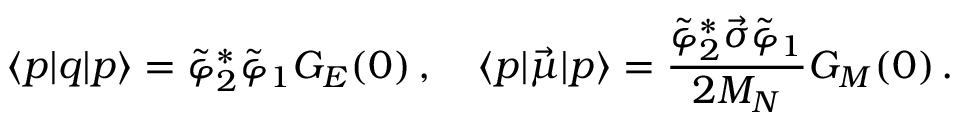<formula> <loc_0><loc_0><loc_500><loc_500>\langle p | q | p \rangle = \tilde { \varphi } _ { 2 } ^ { \ast } \tilde { \varphi } _ { 1 } G _ { E } ( 0 ) \, , \quad \langle p | \vec { \mu } | p \rangle = \frac { \tilde { \varphi } _ { 2 } ^ { \ast } \vec { \sigma } \tilde { \varphi } _ { 1 } } { 2 M _ { N } } G _ { M } ( 0 ) \, .</formula> 